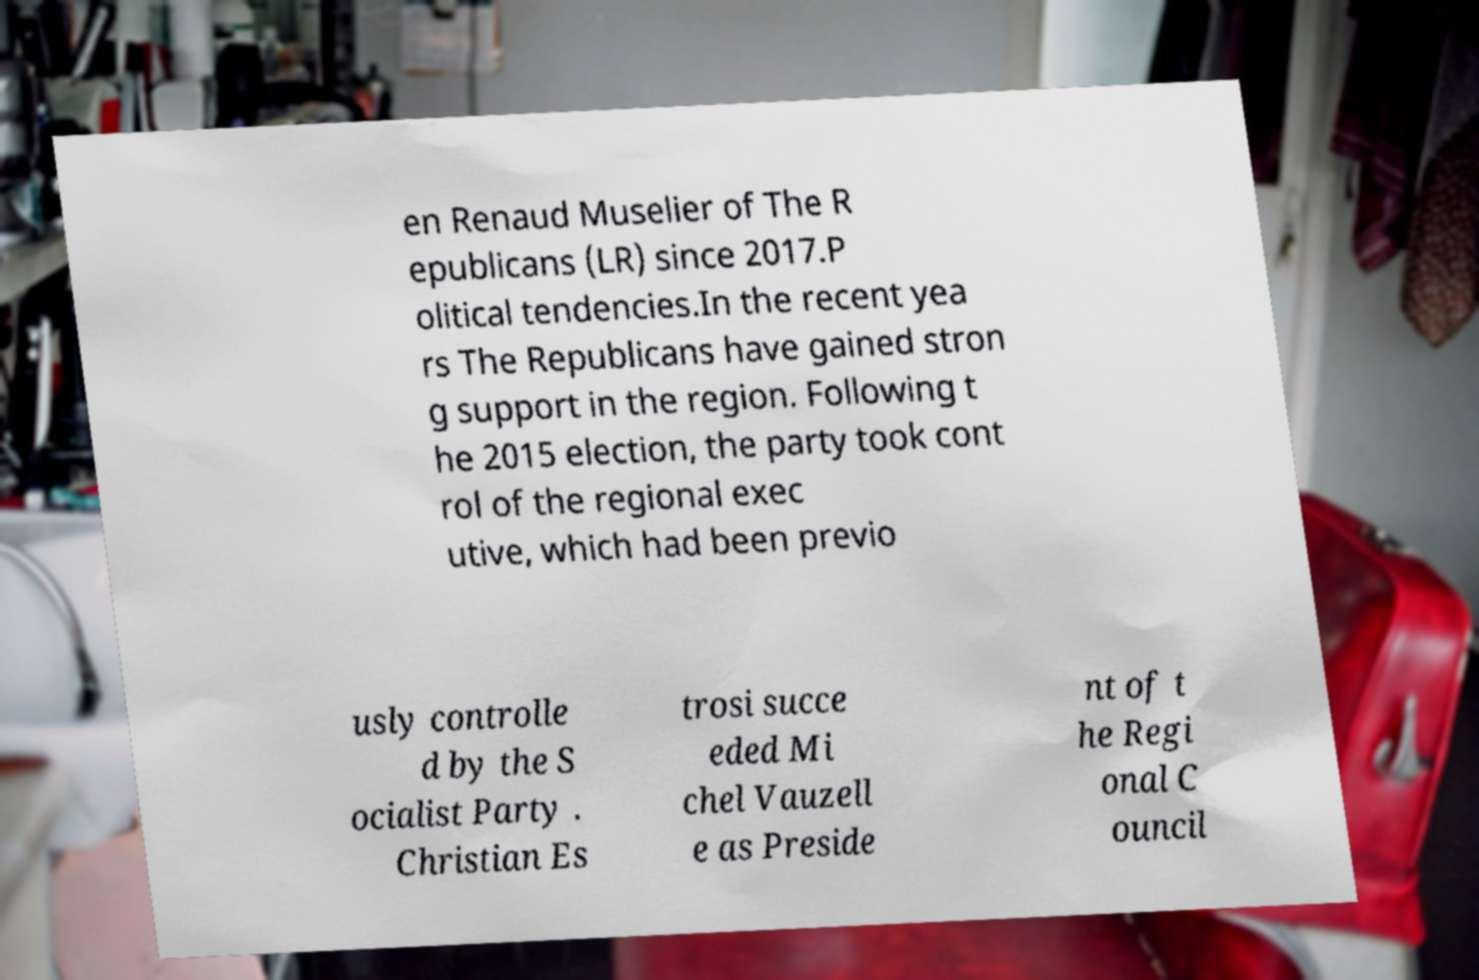What messages or text are displayed in this image? I need them in a readable, typed format. en Renaud Muselier of The R epublicans (LR) since 2017.P olitical tendencies.In the recent yea rs The Republicans have gained stron g support in the region. Following t he 2015 election, the party took cont rol of the regional exec utive, which had been previo usly controlle d by the S ocialist Party . Christian Es trosi succe eded Mi chel Vauzell e as Preside nt of t he Regi onal C ouncil 